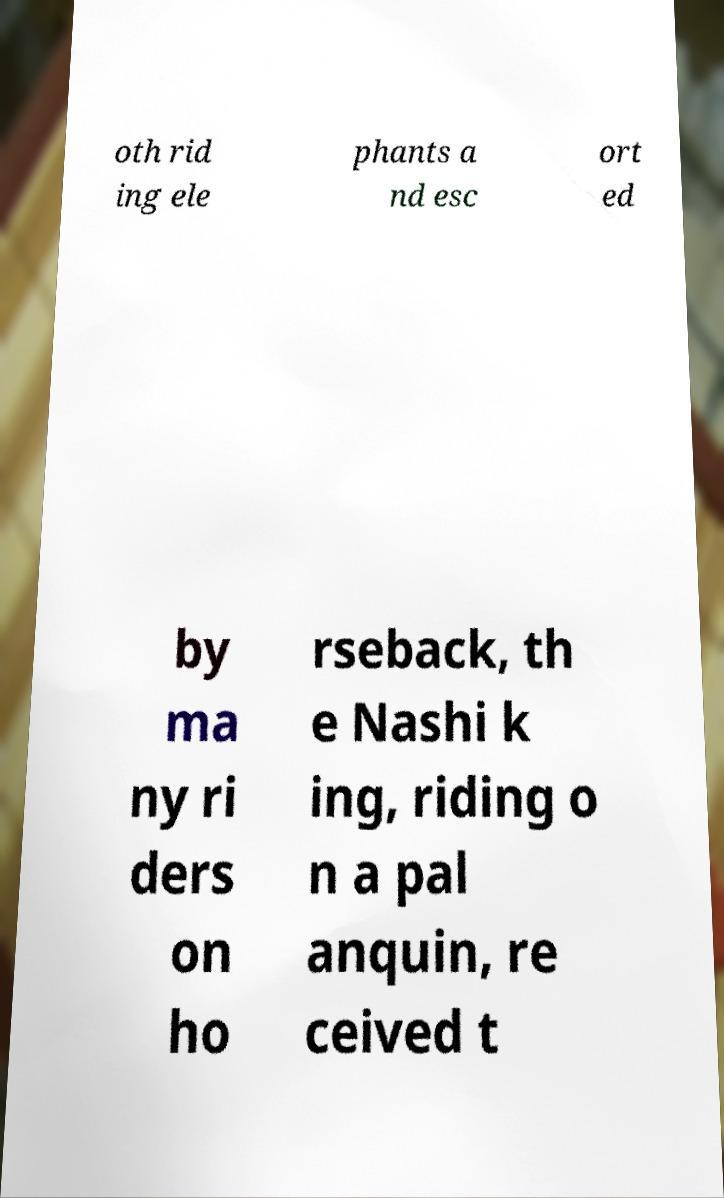There's text embedded in this image that I need extracted. Can you transcribe it verbatim? oth rid ing ele phants a nd esc ort ed by ma ny ri ders on ho rseback, th e Nashi k ing, riding o n a pal anquin, re ceived t 